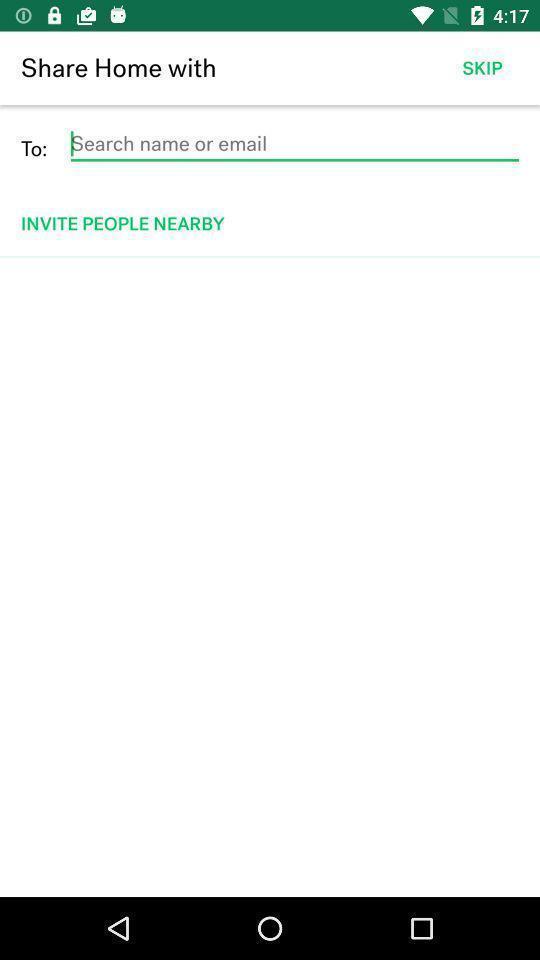What is the overall content of this screenshot? Page showing information of name and email. 